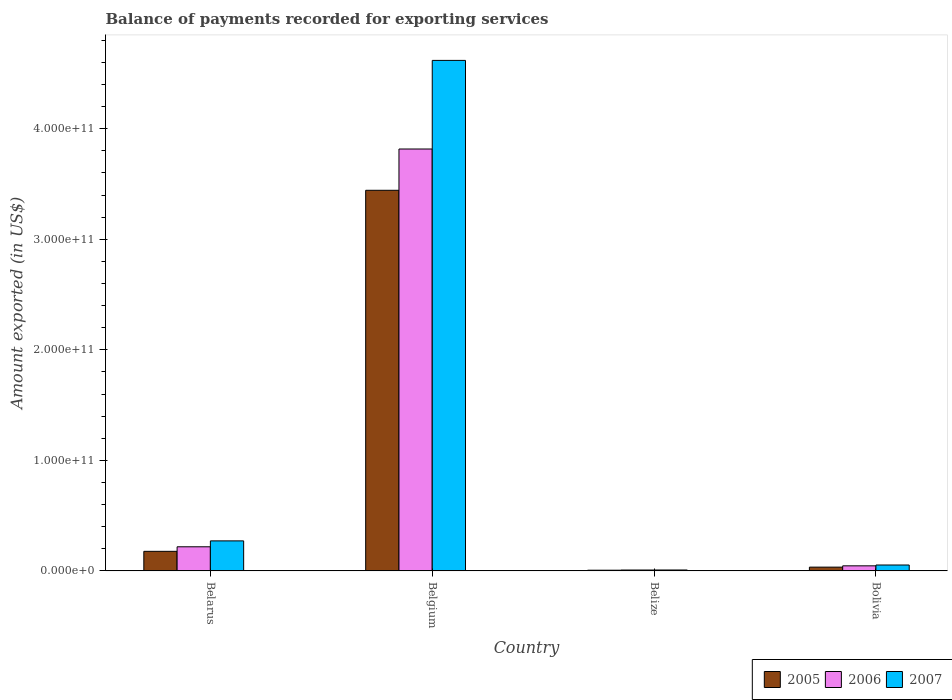How many different coloured bars are there?
Make the answer very short. 3. Are the number of bars on each tick of the X-axis equal?
Offer a very short reply. Yes. How many bars are there on the 1st tick from the right?
Provide a short and direct response. 3. What is the label of the 3rd group of bars from the left?
Provide a succinct answer. Belize. In how many cases, is the number of bars for a given country not equal to the number of legend labels?
Offer a very short reply. 0. What is the amount exported in 2005 in Belize?
Ensure brevity in your answer.  6.22e+08. Across all countries, what is the maximum amount exported in 2006?
Offer a terse response. 3.82e+11. Across all countries, what is the minimum amount exported in 2006?
Your answer should be very brief. 7.86e+08. In which country was the amount exported in 2006 minimum?
Provide a succinct answer. Belize. What is the total amount exported in 2005 in the graph?
Ensure brevity in your answer.  3.66e+11. What is the difference between the amount exported in 2006 in Belgium and that in Bolivia?
Ensure brevity in your answer.  3.77e+11. What is the difference between the amount exported in 2005 in Belize and the amount exported in 2007 in Belarus?
Keep it short and to the point. -2.65e+1. What is the average amount exported in 2007 per country?
Provide a succinct answer. 1.24e+11. What is the difference between the amount exported of/in 2005 and amount exported of/in 2007 in Bolivia?
Provide a short and direct response. -1.92e+09. In how many countries, is the amount exported in 2007 greater than 260000000000 US$?
Make the answer very short. 1. What is the ratio of the amount exported in 2006 in Belize to that in Bolivia?
Ensure brevity in your answer.  0.17. What is the difference between the highest and the second highest amount exported in 2005?
Ensure brevity in your answer.  1.43e+1. What is the difference between the highest and the lowest amount exported in 2007?
Keep it short and to the point. 4.61e+11. Is the sum of the amount exported in 2006 in Belgium and Belize greater than the maximum amount exported in 2005 across all countries?
Your response must be concise. Yes. What does the 3rd bar from the left in Bolivia represents?
Your answer should be very brief. 2007. Is it the case that in every country, the sum of the amount exported in 2006 and amount exported in 2007 is greater than the amount exported in 2005?
Offer a very short reply. Yes. What is the difference between two consecutive major ticks on the Y-axis?
Your answer should be compact. 1.00e+11. Does the graph contain any zero values?
Offer a very short reply. No. How many legend labels are there?
Offer a terse response. 3. What is the title of the graph?
Offer a terse response. Balance of payments recorded for exporting services. What is the label or title of the X-axis?
Offer a very short reply. Country. What is the label or title of the Y-axis?
Your answer should be compact. Amount exported (in US$). What is the Amount exported (in US$) in 2005 in Belarus?
Offer a terse response. 1.77e+1. What is the Amount exported (in US$) in 2006 in Belarus?
Your answer should be very brief. 2.18e+1. What is the Amount exported (in US$) of 2007 in Belarus?
Give a very brief answer. 2.71e+1. What is the Amount exported (in US$) of 2005 in Belgium?
Give a very brief answer. 3.44e+11. What is the Amount exported (in US$) in 2006 in Belgium?
Give a very brief answer. 3.82e+11. What is the Amount exported (in US$) in 2007 in Belgium?
Provide a succinct answer. 4.62e+11. What is the Amount exported (in US$) of 2005 in Belize?
Keep it short and to the point. 6.22e+08. What is the Amount exported (in US$) in 2006 in Belize?
Provide a succinct answer. 7.86e+08. What is the Amount exported (in US$) of 2007 in Belize?
Offer a terse response. 8.23e+08. What is the Amount exported (in US$) in 2005 in Bolivia?
Your response must be concise. 3.40e+09. What is the Amount exported (in US$) of 2006 in Bolivia?
Your answer should be very brief. 4.58e+09. What is the Amount exported (in US$) in 2007 in Bolivia?
Provide a short and direct response. 5.32e+09. Across all countries, what is the maximum Amount exported (in US$) in 2005?
Ensure brevity in your answer.  3.44e+11. Across all countries, what is the maximum Amount exported (in US$) in 2006?
Your answer should be compact. 3.82e+11. Across all countries, what is the maximum Amount exported (in US$) in 2007?
Offer a terse response. 4.62e+11. Across all countries, what is the minimum Amount exported (in US$) in 2005?
Your response must be concise. 6.22e+08. Across all countries, what is the minimum Amount exported (in US$) in 2006?
Provide a succinct answer. 7.86e+08. Across all countries, what is the minimum Amount exported (in US$) of 2007?
Provide a short and direct response. 8.23e+08. What is the total Amount exported (in US$) of 2005 in the graph?
Your response must be concise. 3.66e+11. What is the total Amount exported (in US$) in 2006 in the graph?
Your response must be concise. 4.09e+11. What is the total Amount exported (in US$) in 2007 in the graph?
Give a very brief answer. 4.95e+11. What is the difference between the Amount exported (in US$) of 2005 in Belarus and that in Belgium?
Offer a very short reply. -3.27e+11. What is the difference between the Amount exported (in US$) in 2006 in Belarus and that in Belgium?
Your answer should be compact. -3.60e+11. What is the difference between the Amount exported (in US$) of 2007 in Belarus and that in Belgium?
Offer a terse response. -4.35e+11. What is the difference between the Amount exported (in US$) of 2005 in Belarus and that in Belize?
Ensure brevity in your answer.  1.71e+1. What is the difference between the Amount exported (in US$) of 2006 in Belarus and that in Belize?
Ensure brevity in your answer.  2.10e+1. What is the difference between the Amount exported (in US$) in 2007 in Belarus and that in Belize?
Your answer should be compact. 2.63e+1. What is the difference between the Amount exported (in US$) in 2005 in Belarus and that in Bolivia?
Provide a short and direct response. 1.43e+1. What is the difference between the Amount exported (in US$) in 2006 in Belarus and that in Bolivia?
Provide a succinct answer. 1.72e+1. What is the difference between the Amount exported (in US$) of 2007 in Belarus and that in Bolivia?
Your answer should be compact. 2.18e+1. What is the difference between the Amount exported (in US$) in 2005 in Belgium and that in Belize?
Provide a succinct answer. 3.44e+11. What is the difference between the Amount exported (in US$) of 2006 in Belgium and that in Belize?
Your response must be concise. 3.81e+11. What is the difference between the Amount exported (in US$) in 2007 in Belgium and that in Belize?
Offer a terse response. 4.61e+11. What is the difference between the Amount exported (in US$) in 2005 in Belgium and that in Bolivia?
Give a very brief answer. 3.41e+11. What is the difference between the Amount exported (in US$) of 2006 in Belgium and that in Bolivia?
Your answer should be compact. 3.77e+11. What is the difference between the Amount exported (in US$) in 2007 in Belgium and that in Bolivia?
Your response must be concise. 4.57e+11. What is the difference between the Amount exported (in US$) of 2005 in Belize and that in Bolivia?
Your answer should be compact. -2.78e+09. What is the difference between the Amount exported (in US$) of 2006 in Belize and that in Bolivia?
Your response must be concise. -3.80e+09. What is the difference between the Amount exported (in US$) of 2007 in Belize and that in Bolivia?
Offer a very short reply. -4.50e+09. What is the difference between the Amount exported (in US$) of 2005 in Belarus and the Amount exported (in US$) of 2006 in Belgium?
Keep it short and to the point. -3.64e+11. What is the difference between the Amount exported (in US$) in 2005 in Belarus and the Amount exported (in US$) in 2007 in Belgium?
Offer a terse response. -4.44e+11. What is the difference between the Amount exported (in US$) in 2006 in Belarus and the Amount exported (in US$) in 2007 in Belgium?
Offer a very short reply. -4.40e+11. What is the difference between the Amount exported (in US$) in 2005 in Belarus and the Amount exported (in US$) in 2006 in Belize?
Your answer should be very brief. 1.69e+1. What is the difference between the Amount exported (in US$) of 2005 in Belarus and the Amount exported (in US$) of 2007 in Belize?
Provide a succinct answer. 1.69e+1. What is the difference between the Amount exported (in US$) of 2006 in Belarus and the Amount exported (in US$) of 2007 in Belize?
Give a very brief answer. 2.10e+1. What is the difference between the Amount exported (in US$) in 2005 in Belarus and the Amount exported (in US$) in 2006 in Bolivia?
Keep it short and to the point. 1.31e+1. What is the difference between the Amount exported (in US$) in 2005 in Belarus and the Amount exported (in US$) in 2007 in Bolivia?
Your answer should be compact. 1.24e+1. What is the difference between the Amount exported (in US$) in 2006 in Belarus and the Amount exported (in US$) in 2007 in Bolivia?
Offer a very short reply. 1.65e+1. What is the difference between the Amount exported (in US$) in 2005 in Belgium and the Amount exported (in US$) in 2006 in Belize?
Offer a terse response. 3.44e+11. What is the difference between the Amount exported (in US$) in 2005 in Belgium and the Amount exported (in US$) in 2007 in Belize?
Your answer should be very brief. 3.44e+11. What is the difference between the Amount exported (in US$) in 2006 in Belgium and the Amount exported (in US$) in 2007 in Belize?
Provide a succinct answer. 3.81e+11. What is the difference between the Amount exported (in US$) of 2005 in Belgium and the Amount exported (in US$) of 2006 in Bolivia?
Keep it short and to the point. 3.40e+11. What is the difference between the Amount exported (in US$) in 2005 in Belgium and the Amount exported (in US$) in 2007 in Bolivia?
Provide a short and direct response. 3.39e+11. What is the difference between the Amount exported (in US$) in 2006 in Belgium and the Amount exported (in US$) in 2007 in Bolivia?
Provide a short and direct response. 3.76e+11. What is the difference between the Amount exported (in US$) of 2005 in Belize and the Amount exported (in US$) of 2006 in Bolivia?
Give a very brief answer. -3.96e+09. What is the difference between the Amount exported (in US$) of 2005 in Belize and the Amount exported (in US$) of 2007 in Bolivia?
Give a very brief answer. -4.70e+09. What is the difference between the Amount exported (in US$) of 2006 in Belize and the Amount exported (in US$) of 2007 in Bolivia?
Make the answer very short. -4.54e+09. What is the average Amount exported (in US$) in 2005 per country?
Ensure brevity in your answer.  9.15e+1. What is the average Amount exported (in US$) of 2006 per country?
Your response must be concise. 1.02e+11. What is the average Amount exported (in US$) of 2007 per country?
Offer a very short reply. 1.24e+11. What is the difference between the Amount exported (in US$) of 2005 and Amount exported (in US$) of 2006 in Belarus?
Provide a succinct answer. -4.11e+09. What is the difference between the Amount exported (in US$) in 2005 and Amount exported (in US$) in 2007 in Belarus?
Keep it short and to the point. -9.44e+09. What is the difference between the Amount exported (in US$) in 2006 and Amount exported (in US$) in 2007 in Belarus?
Make the answer very short. -5.33e+09. What is the difference between the Amount exported (in US$) of 2005 and Amount exported (in US$) of 2006 in Belgium?
Your response must be concise. -3.73e+1. What is the difference between the Amount exported (in US$) of 2005 and Amount exported (in US$) of 2007 in Belgium?
Your response must be concise. -1.18e+11. What is the difference between the Amount exported (in US$) of 2006 and Amount exported (in US$) of 2007 in Belgium?
Offer a terse response. -8.02e+1. What is the difference between the Amount exported (in US$) of 2005 and Amount exported (in US$) of 2006 in Belize?
Offer a terse response. -1.64e+08. What is the difference between the Amount exported (in US$) in 2005 and Amount exported (in US$) in 2007 in Belize?
Your response must be concise. -2.02e+08. What is the difference between the Amount exported (in US$) of 2006 and Amount exported (in US$) of 2007 in Belize?
Offer a terse response. -3.73e+07. What is the difference between the Amount exported (in US$) of 2005 and Amount exported (in US$) of 2006 in Bolivia?
Keep it short and to the point. -1.18e+09. What is the difference between the Amount exported (in US$) of 2005 and Amount exported (in US$) of 2007 in Bolivia?
Offer a very short reply. -1.92e+09. What is the difference between the Amount exported (in US$) of 2006 and Amount exported (in US$) of 2007 in Bolivia?
Make the answer very short. -7.40e+08. What is the ratio of the Amount exported (in US$) in 2005 in Belarus to that in Belgium?
Offer a terse response. 0.05. What is the ratio of the Amount exported (in US$) of 2006 in Belarus to that in Belgium?
Offer a terse response. 0.06. What is the ratio of the Amount exported (in US$) of 2007 in Belarus to that in Belgium?
Offer a very short reply. 0.06. What is the ratio of the Amount exported (in US$) in 2005 in Belarus to that in Belize?
Provide a short and direct response. 28.47. What is the ratio of the Amount exported (in US$) of 2006 in Belarus to that in Belize?
Your response must be concise. 27.75. What is the ratio of the Amount exported (in US$) of 2007 in Belarus to that in Belize?
Make the answer very short. 32.97. What is the ratio of the Amount exported (in US$) in 2005 in Belarus to that in Bolivia?
Offer a very short reply. 5.21. What is the ratio of the Amount exported (in US$) in 2006 in Belarus to that in Bolivia?
Keep it short and to the point. 4.76. What is the ratio of the Amount exported (in US$) of 2007 in Belarus to that in Bolivia?
Keep it short and to the point. 5.1. What is the ratio of the Amount exported (in US$) in 2005 in Belgium to that in Belize?
Ensure brevity in your answer.  553.81. What is the ratio of the Amount exported (in US$) of 2006 in Belgium to that in Belize?
Provide a succinct answer. 485.58. What is the ratio of the Amount exported (in US$) in 2007 in Belgium to that in Belize?
Provide a succinct answer. 560.97. What is the ratio of the Amount exported (in US$) in 2005 in Belgium to that in Bolivia?
Give a very brief answer. 101.26. What is the ratio of the Amount exported (in US$) of 2006 in Belgium to that in Bolivia?
Make the answer very short. 83.25. What is the ratio of the Amount exported (in US$) of 2007 in Belgium to that in Bolivia?
Make the answer very short. 86.74. What is the ratio of the Amount exported (in US$) of 2005 in Belize to that in Bolivia?
Make the answer very short. 0.18. What is the ratio of the Amount exported (in US$) in 2006 in Belize to that in Bolivia?
Your answer should be very brief. 0.17. What is the ratio of the Amount exported (in US$) in 2007 in Belize to that in Bolivia?
Ensure brevity in your answer.  0.15. What is the difference between the highest and the second highest Amount exported (in US$) in 2005?
Your response must be concise. 3.27e+11. What is the difference between the highest and the second highest Amount exported (in US$) in 2006?
Offer a terse response. 3.60e+11. What is the difference between the highest and the second highest Amount exported (in US$) of 2007?
Keep it short and to the point. 4.35e+11. What is the difference between the highest and the lowest Amount exported (in US$) in 2005?
Offer a very short reply. 3.44e+11. What is the difference between the highest and the lowest Amount exported (in US$) in 2006?
Your answer should be very brief. 3.81e+11. What is the difference between the highest and the lowest Amount exported (in US$) in 2007?
Provide a succinct answer. 4.61e+11. 